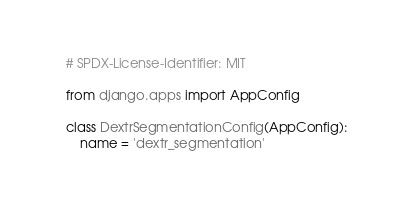Convert code to text. <code><loc_0><loc_0><loc_500><loc_500><_Python_># SPDX-License-Identifier: MIT

from django.apps import AppConfig

class DextrSegmentationConfig(AppConfig):
    name = 'dextr_segmentation'
</code> 